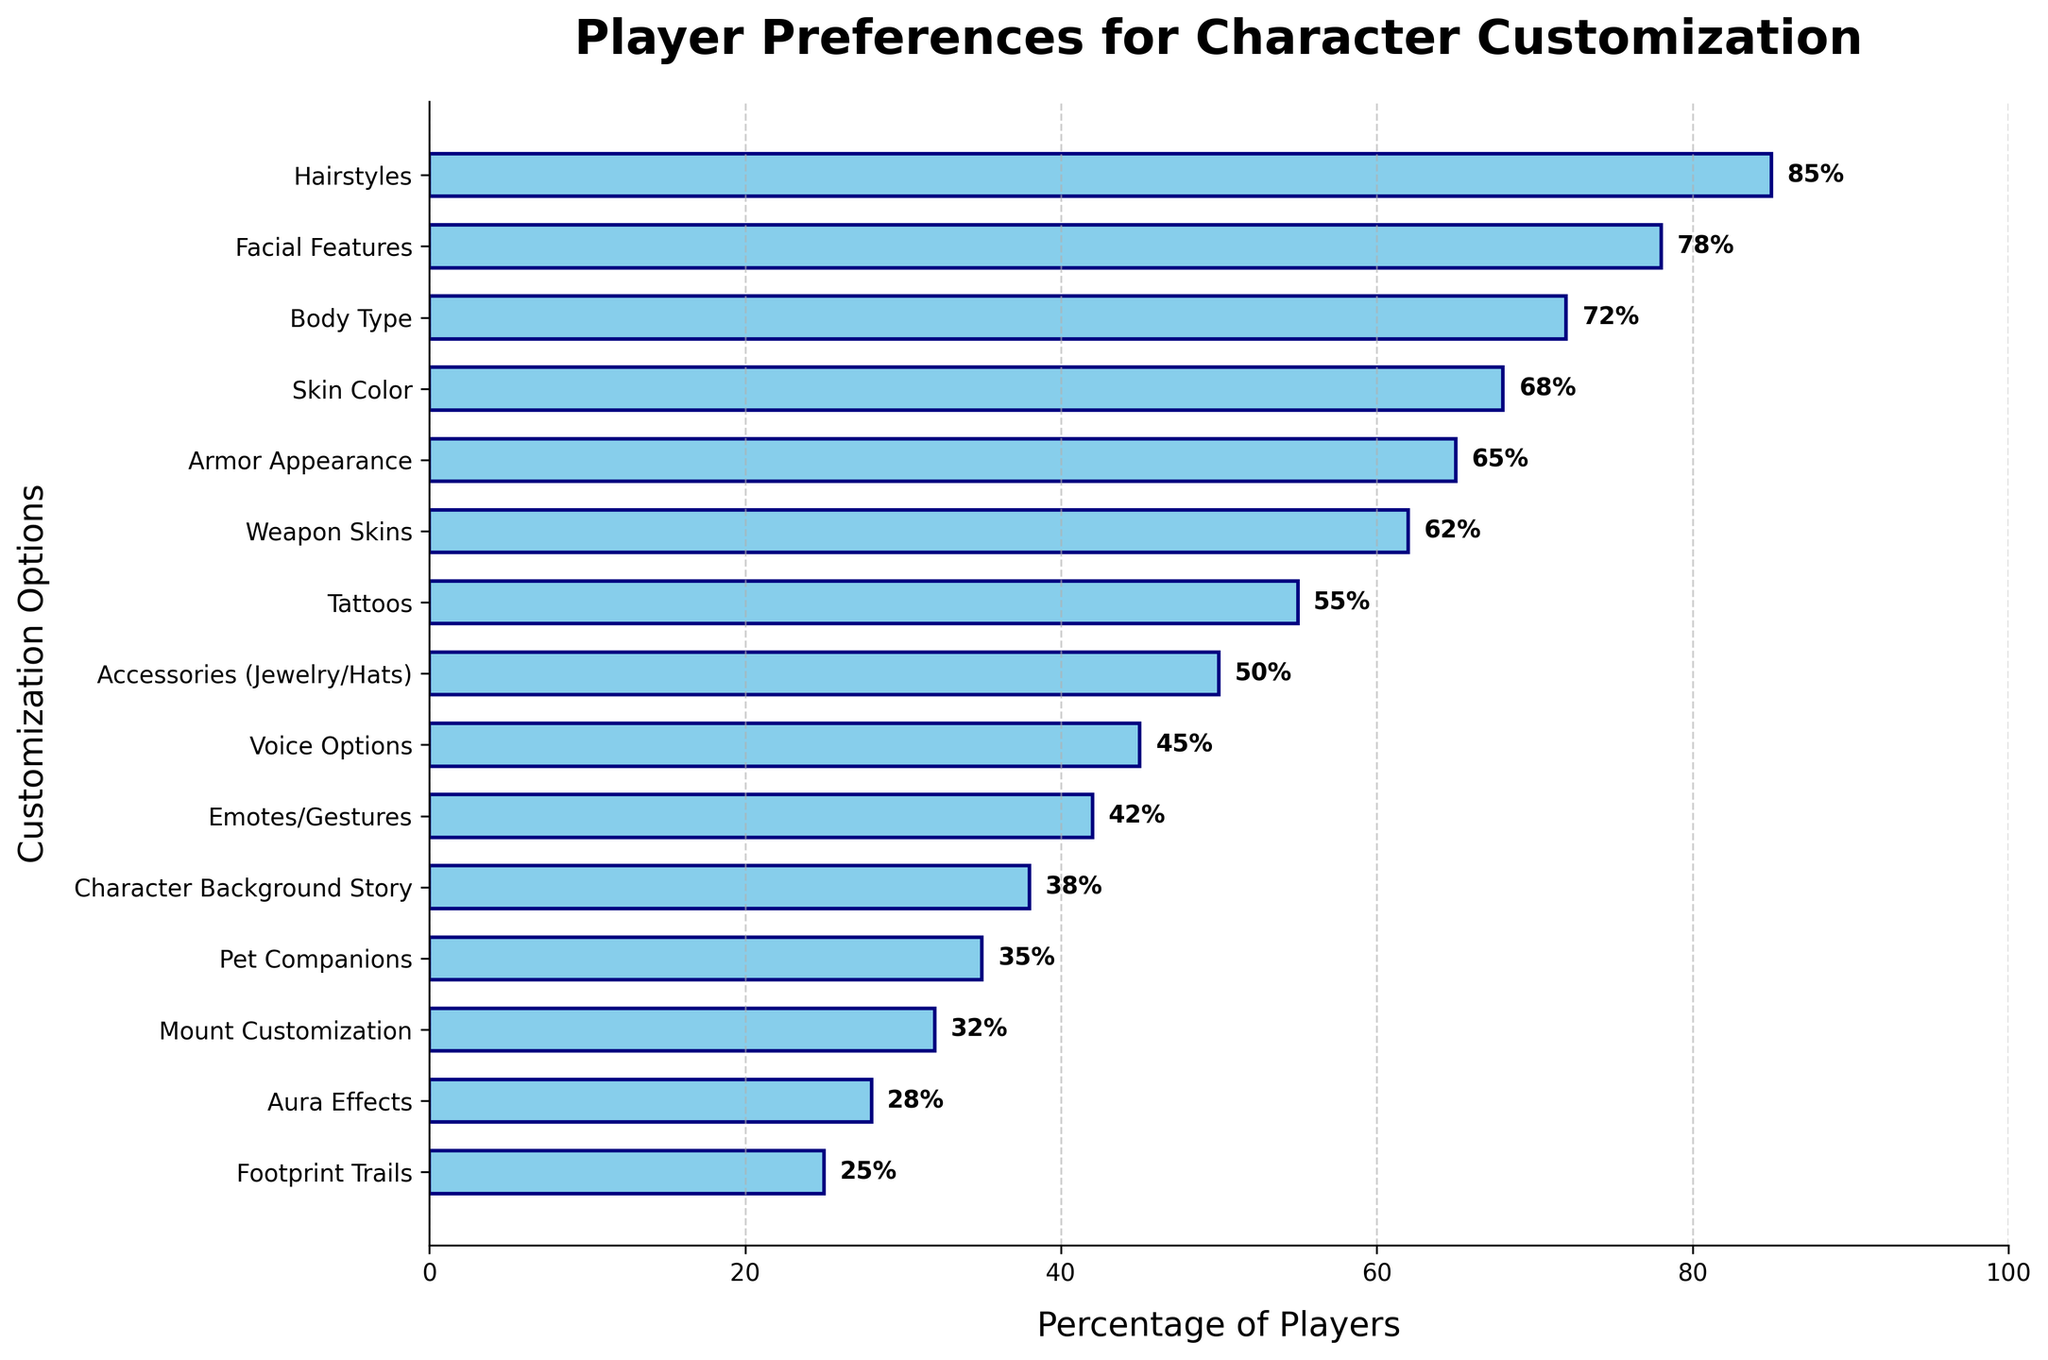Which character customization option is preferred by the highest percentage of players? To find this, look for the tallest bar in the bar chart. It represents the option that is preferred by the highest percentage of players.
Answer: Hairstyles How many percentage points more popular are Hairstyles compared to Mount Customization? Identify the percentages for both Hairstyles (85%) and Mount Customization (32%). Subtract the percentage for Mount Customization from Hairstyles (85% - 32%).
Answer: 53 List all customization options that have a player preference above 70%. Check each bar and note all options with a percentage higher than 70%.
Answer: Hairstyles, Facial Features, Body Type Which customization option is just below Accessories (Jewelry/Hats) in terms of percentage of players? Locate the bar for Accessories (Jewelry/Hats) (50%) and identify the bar directly below it.
Answer: Voice Options What is the percentage range covered by the customization options? Determine this by finding the difference between the highest (Hairstyles at 85%) and the lowest percentage (Footprint Trails at 25%).
Answer: 60 Comparing Weapon Skins and Emotes/Gestures, which is more popular and by how many percentage points? Identify the percentages for Weapon Skins (62%) and Emotes/Gestures (42%). Subtract the smaller from the larger (62% - 42%).
Answer: Weapon Skins by 20 What is the average percentage preference across all customization options? Sum all the percentages and divide by the number of options. (85 + 78 + 72 + 68 + 65 + 62 + 55 + 50 + 45 + 42 + 38 + 35 + 32 + 28 + 25) / 15 = 54.
Answer: 54 Identify the least popular customization option and state its percentage of players. Find the shortest bar in the bar chart. This bar represents the least popular option.
Answer: Footprint Trails (25%) Compare the popularity of Skin Color to Armor Appearance. Which one is preferred by more players? Check the percentages for Skin Color (68%) and Armor Appearance (65%). Identify the larger percentage.
Answer: Skin Color How much more popular are Tattoos compared to Aura Effects? Identify the percentages for Tattoos (55%) and Aura Effects (28%). Subtract Aura Effects from Tattoos (55% - 28%).
Answer: 27 